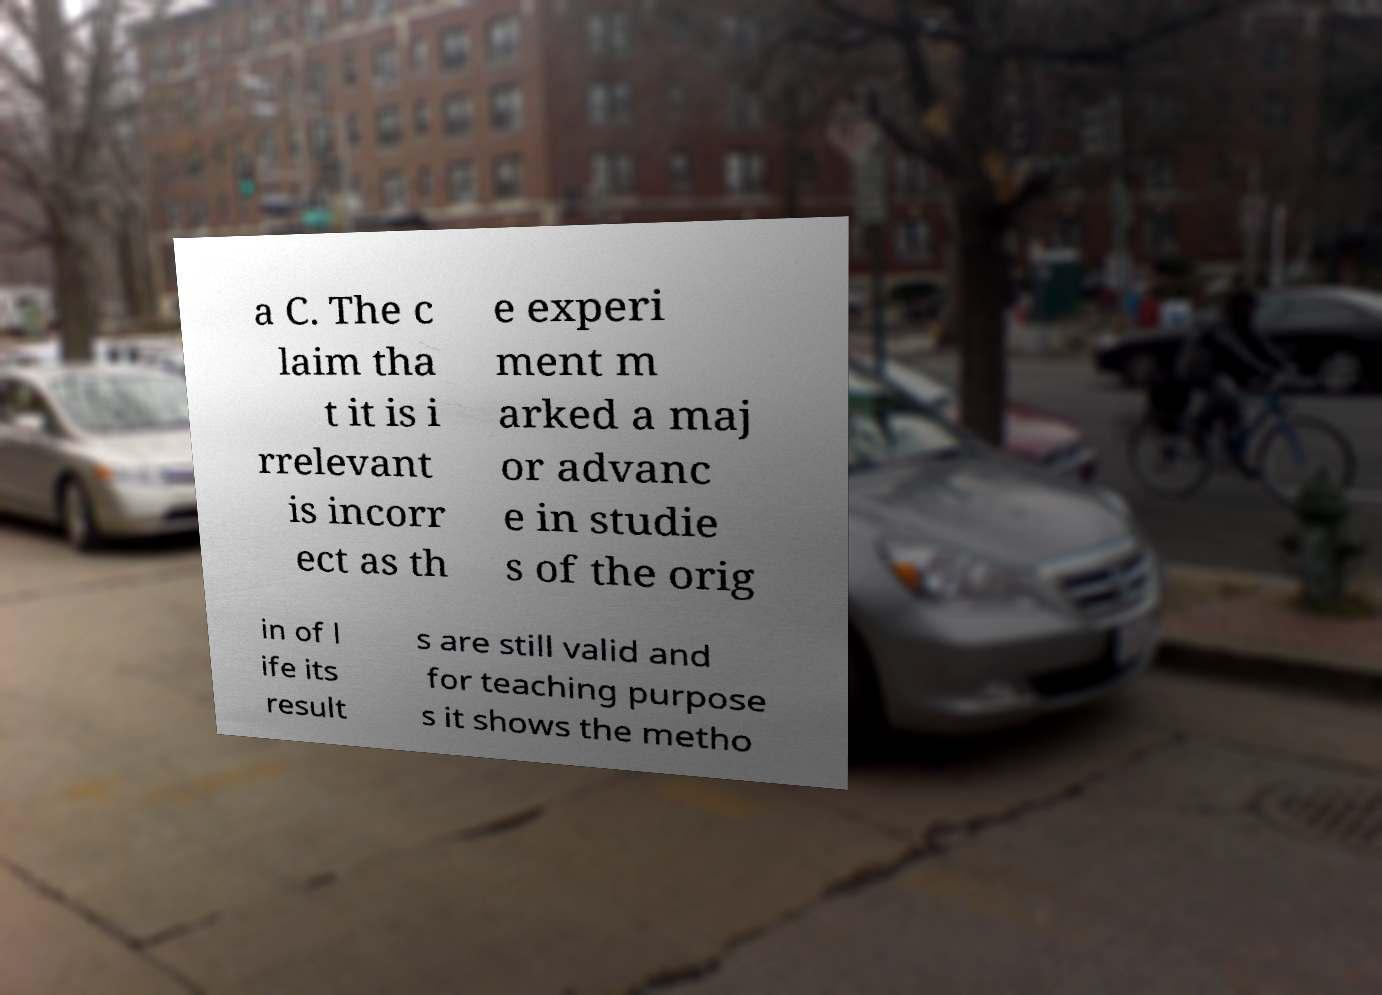For documentation purposes, I need the text within this image transcribed. Could you provide that? a C. The c laim tha t it is i rrelevant is incorr ect as th e experi ment m arked a maj or advanc e in studie s of the orig in of l ife its result s are still valid and for teaching purpose s it shows the metho 